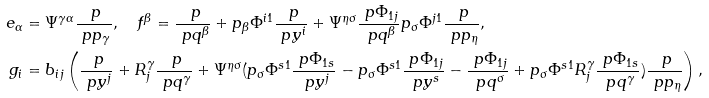Convert formula to latex. <formula><loc_0><loc_0><loc_500><loc_500>e _ { \alpha } & = \Psi ^ { \gamma \alpha } \frac { \ p } { \ p p _ { \gamma } } , \quad f ^ { \beta } = \frac { \ p } { \ p q ^ { \beta } } + p _ { \beta } \Phi ^ { i 1 } \frac { \ p } { \ p y ^ { i } } + \Psi ^ { \eta \sigma } \frac { \ p \Phi _ { 1 j } } { \ p q ^ { \beta } } p _ { \sigma } \Phi ^ { j 1 } \frac { \ p } { \ p p _ { \eta } } , \\ g _ { i } & = b _ { i j } \left ( \frac { \ p } { \ p y ^ { j } } + R ^ { \gamma } _ { j } \frac { \ p } { \ p q ^ { \gamma } } + \Psi ^ { \eta \sigma } ( p _ { \sigma } \Phi ^ { s 1 } \frac { \ p \Phi _ { 1 s } } { \ p y ^ { j } } - p _ { \sigma } \Phi ^ { s 1 } \frac { \ p \Phi _ { 1 j } } { \ p y ^ { s } } - \frac { \ p \Phi _ { 1 j } } { \ p q ^ { \sigma } } + p _ { \sigma } \Phi ^ { s 1 } R ^ { \gamma } _ { j } \frac { \ p \Phi _ { 1 s } } { \ p q ^ { \gamma } } ) \frac { \ p } { \ p p _ { \eta } } \right ) ,</formula> 